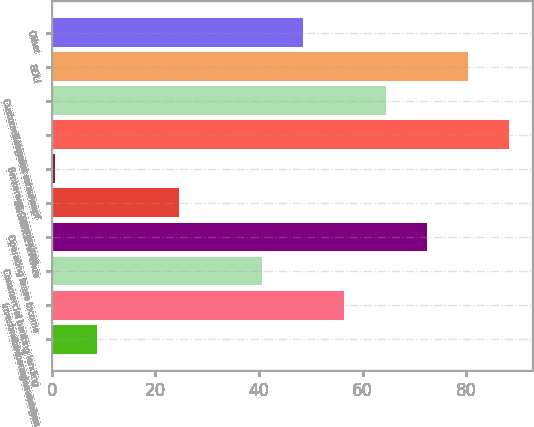Convert chart to OTSL. <chart><loc_0><loc_0><loc_500><loc_500><bar_chart><fcel>Bank service charges<fcel>Investment management fees<fcel>Commercial banking lending<fcel>Operating lease income<fcel>Insurance revenue<fcel>Brokerage commissions<fcel>Net gains on sales of<fcel>Customer interest rate swap<fcel>BOLI<fcel>Other<nl><fcel>8.67<fcel>56.49<fcel>40.55<fcel>72.43<fcel>24.61<fcel>0.7<fcel>88.37<fcel>64.46<fcel>80.4<fcel>48.52<nl></chart> 